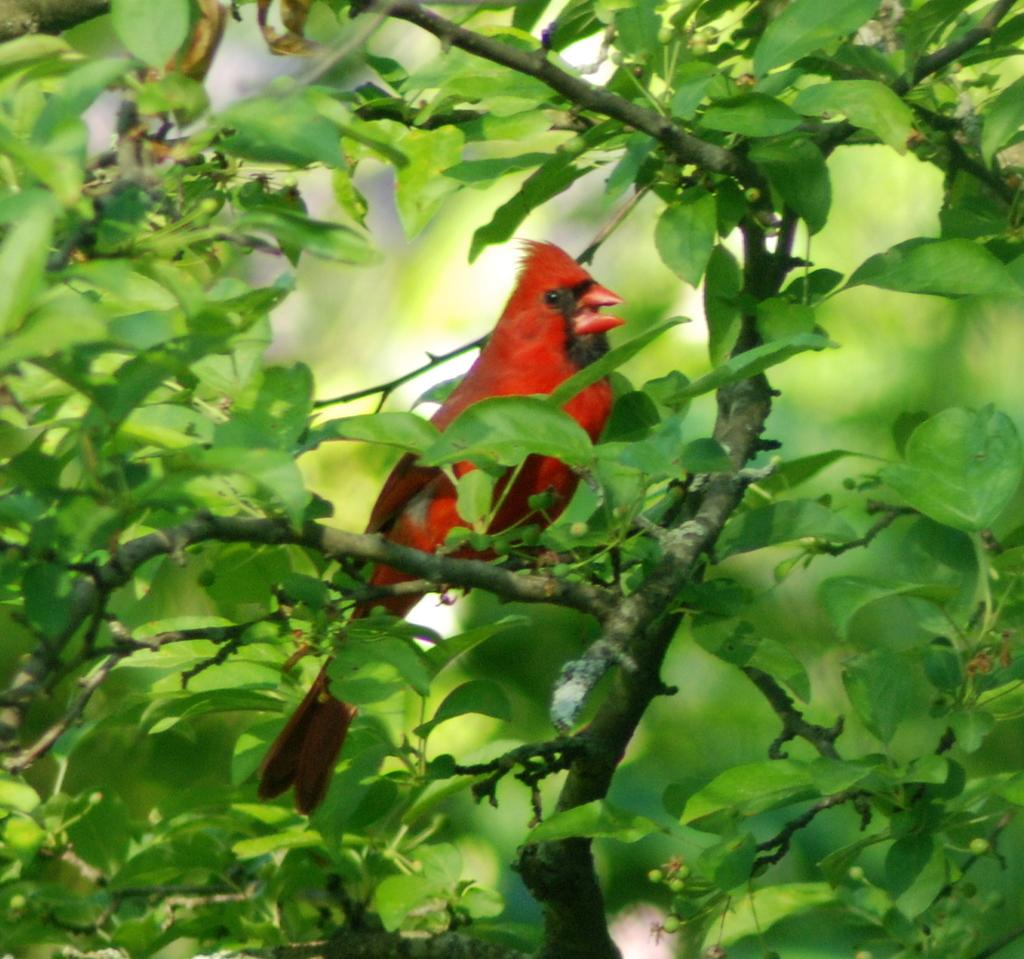What type of animal is in the image? There is a red color bird in the image. Where is the bird located in the image? The bird is sitting on a branch. What color are the leaves in the image? The leaves in the image are green color. Can you see any rabbits or cats in the image? No, there are no rabbits or cats present in the image. Are there any stockings visible in the image? No, there are no stockings visible in the image. 